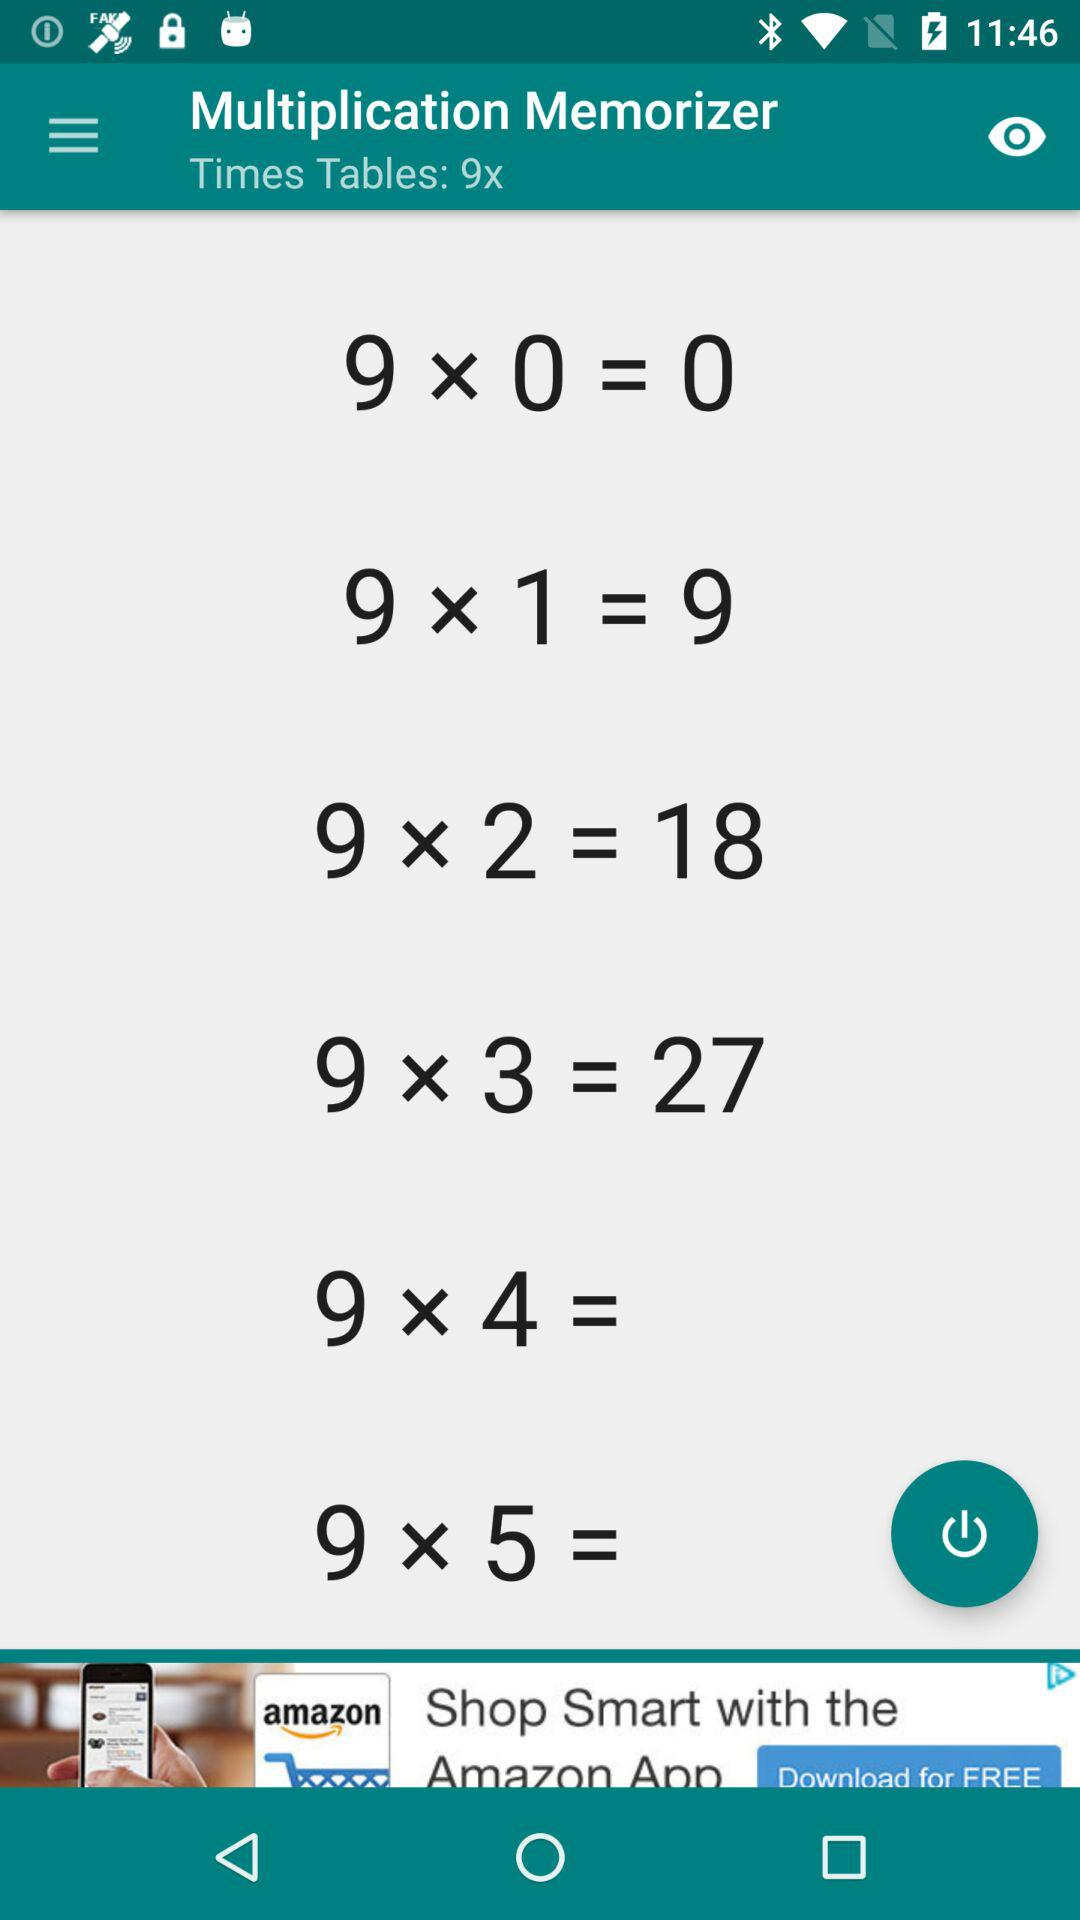How many times tables are shown on the screen?
Answer the question using a single word or phrase. 6 